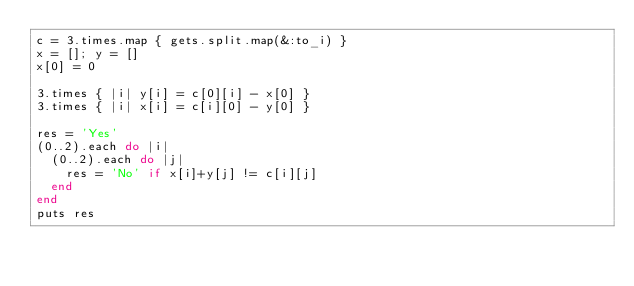<code> <loc_0><loc_0><loc_500><loc_500><_Ruby_>c = 3.times.map { gets.split.map(&:to_i) }
x = []; y = []
x[0] = 0

3.times { |i| y[i] = c[0][i] - x[0] }
3.times { |i| x[i] = c[i][0] - y[0] }

res = 'Yes'
(0..2).each do |i|
  (0..2).each do |j|
    res = 'No' if x[i]+y[j] != c[i][j]
  end
end
puts res</code> 